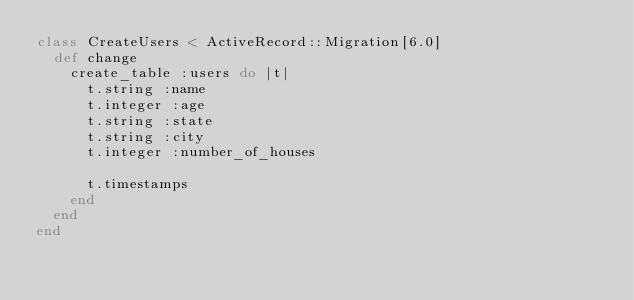<code> <loc_0><loc_0><loc_500><loc_500><_Ruby_>class CreateUsers < ActiveRecord::Migration[6.0]
  def change
    create_table :users do |t|
      t.string :name
      t.integer :age
      t.string :state
      t.string :city
      t.integer :number_of_houses

      t.timestamps
    end
  end
end
</code> 